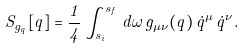<formula> <loc_0><loc_0><loc_500><loc_500>S _ { g _ { q } } [ q ] = \frac { 1 } { 4 } \int _ { s _ { i } } ^ { s _ { f } } \, d \omega \, g _ { \mu \nu } ( q ) \, \dot { q } ^ { \mu } \, \dot { q } ^ { \nu } .</formula> 